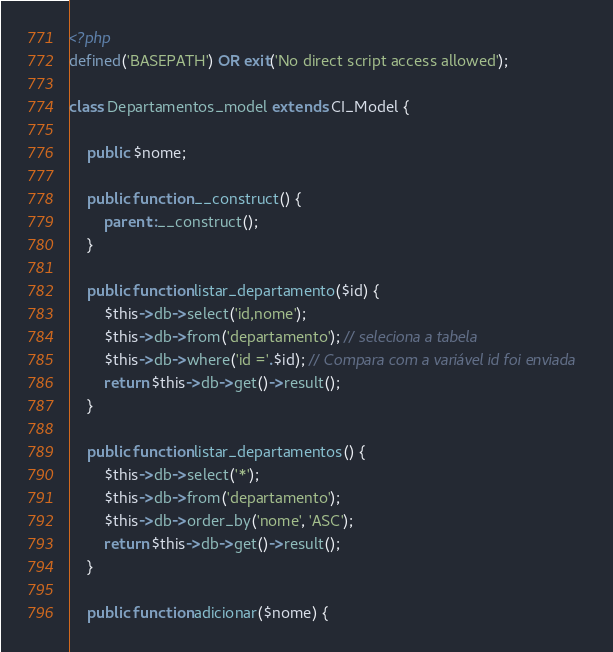Convert code to text. <code><loc_0><loc_0><loc_500><loc_500><_PHP_><?php
defined('BASEPATH') OR exit('No direct script access allowed');

class Departamentos_model extends CI_Model {

	public $nome;

	public function __construct() {
		parent::__construct();
	}

	public function listar_departamento($id) {
		$this->db->select('id,nome');
		$this->db->from('departamento'); // seleciona a tabela
		$this->db->where('id ='.$id); // Compara com a variável id foi enviada
		return $this->db->get()->result();
	}

	public function listar_departamentos() {
		$this->db->select('*');
		$this->db->from('departamento'); 
		$this->db->order_by('nome', 'ASC');
		return $this->db->get()->result();
	}

	public function adicionar($nome) {</code> 